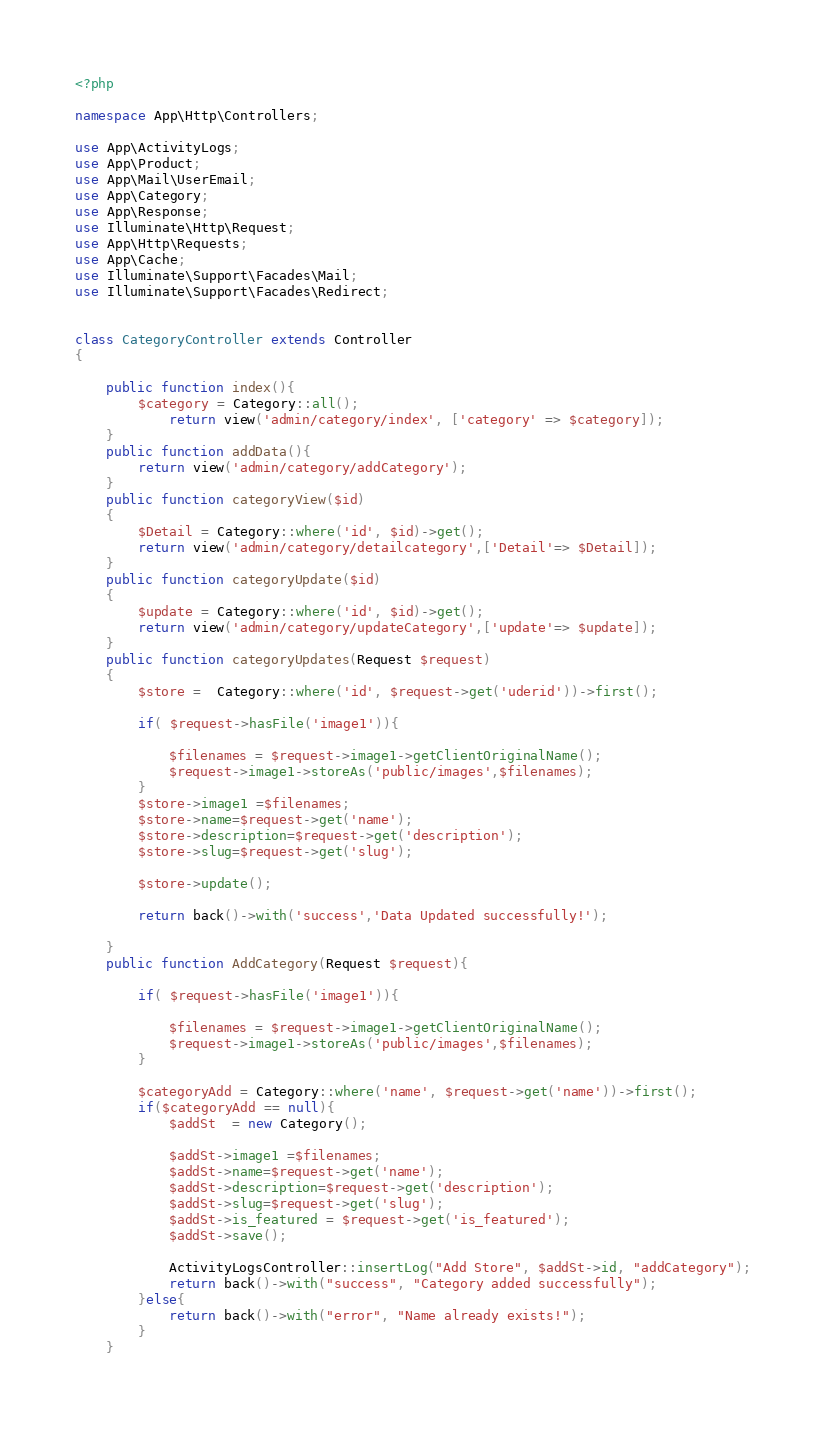<code> <loc_0><loc_0><loc_500><loc_500><_PHP_><?php

namespace App\Http\Controllers;

use App\ActivityLogs;
use App\Product;
use App\Mail\UserEmail;
use App\Category;
use App\Response;
use Illuminate\Http\Request;
use App\Http\Requests;
use App\Cache;
use Illuminate\Support\Facades\Mail;
use Illuminate\Support\Facades\Redirect;


class CategoryController extends Controller
{

    public function index(){
        $category = Category::all();
            return view('admin/category/index', ['category' => $category]);
    }
    public function addData(){
        return view('admin/category/addCategory');
    }
    public function categoryView($id)
    {
        $Detail = Category::where('id', $id)->get();
        return view('admin/category/detailcategory',['Detail'=> $Detail]);
    }
    public function categoryUpdate($id)
    {
        $update = Category::where('id', $id)->get();
        return view('admin/category/updateCategory',['update'=> $update]);
    }
    public function categoryUpdates(Request $request)
    {
        $store =  Category::where('id', $request->get('uderid'))->first();

        if( $request->hasFile('image1')){

            $filenames = $request->image1->getClientOriginalName();
            $request->image1->storeAs('public/images',$filenames);
        }
        $store->image1 =$filenames;
        $store->name=$request->get('name');
        $store->description=$request->get('description');
        $store->slug=$request->get('slug');

        $store->update();

        return back()->with('success','Data Updated successfully!');

    }
    public function AddCategory(Request $request){

        if( $request->hasFile('image1')){

            $filenames = $request->image1->getClientOriginalName();
            $request->image1->storeAs('public/images',$filenames);
        }

        $categoryAdd = Category::where('name', $request->get('name'))->first();
        if($categoryAdd == null){
            $addSt  = new Category();

            $addSt->image1 =$filenames;
            $addSt->name=$request->get('name');
            $addSt->description=$request->get('description');
            $addSt->slug=$request->get('slug');
            $addSt->is_featured = $request->get('is_featured');
            $addSt->save();

            ActivityLogsController::insertLog("Add Store", $addSt->id, "addCategory");
            return back()->with("success", "Category added successfully");
        }else{
            return back()->with("error", "Name already exists!");
        }
    }</code> 